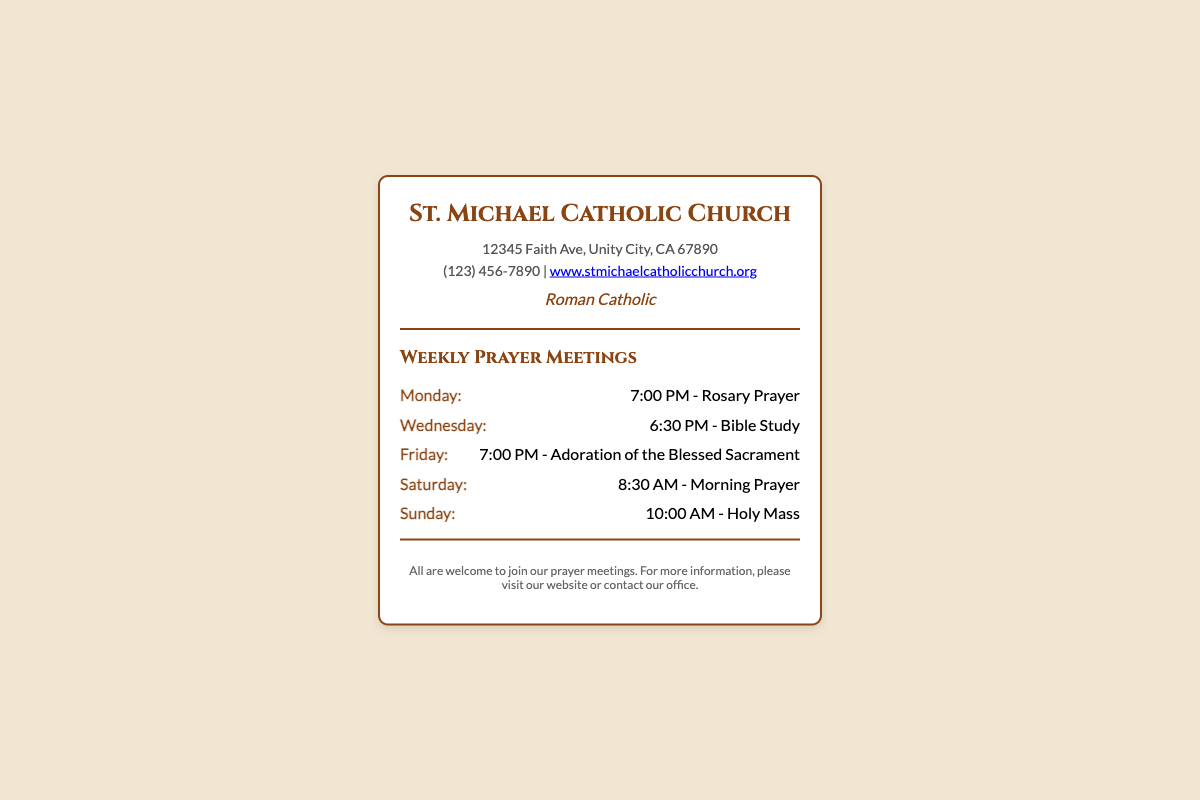What is the name of the church? The name of the church is stated at the top of the business card.
Answer: St. Michael Catholic Church What is the address of the church? The address is provided in the document under the contact information section.
Answer: 12345 Faith Ave, Unity City, CA 67890 What is the phone number for the church? The phone number is listed in the contact section of the business card.
Answer: (123) 456-7890 What is the schedule for the Sunday prayer meeting? The schedule is outlined in the weekly prayer meetings section.
Answer: 10:00 AM - Holy Mass How many types of prayer meetings are listed? The number of different prayer meetings can be counted from the weekly schedule.
Answer: Five What is the time for the Rosary Prayer on Monday? The time for the Rosary Prayer is included in the schedule under Monday.
Answer: 7:00 PM What type of affiliation is mentioned for the church? The affiliation stated at the bottom of the header section of the card indicates the church's identity.
Answer: Roman Catholic Are guests welcome to the prayer meetings? The footer mentions this explicitly, indicating the inclusiveness of the meetings.
Answer: Yes On which day does the Bible Study take place? The day for the Bible Study is clearly stated in the weekly meeting schedule.
Answer: Wednesday 